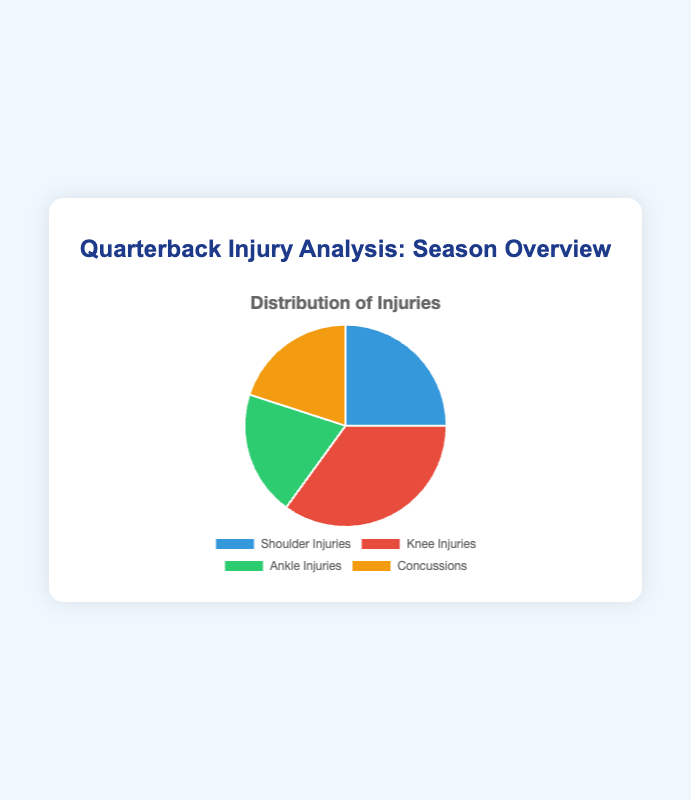Which injury type is the most common? By looking at the pie chart, the section representing knee injuries is the largest, with a percentage of 35%. Hence, knee injuries are the most common.
Answer: Knee Injuries What is the combined percentage of ankle injuries and concussions? The pie chart shows that ankle injuries and concussions each occupy 20% of the chart. Adding these together, 20% + 20% = 40%.
Answer: 40% Which injury types have the same percentage? The pie chart shows identical sizes for ankle injuries and concussions; each occupies 20%. Therefore, both have the same percentage.
Answer: Ankle Injuries and Concussions How does the percentage of shoulder injuries compare to knee injuries? The pie chart reveals that shoulder injuries account for 25%, whereas knee injuries account for 35%. This indicates that knee injuries are more frequent than shoulder injuries.
Answer: Knee Injuries are more frequent than Shoulder Injuries What percentage of injuries are neither knee injuries nor ankle injuries? The pie chart indicates that knee injuries are 35% and ankle injuries are 20%. Calculating the total percentage for both, we get 35% + 20% = 55%. Subtracting this from the total percentage (100%) gives 100% - 55% = 45%.
Answer: 45% Which section of the pie chart is represented by the blue color? According to the pie chart's color distribution, the blue section represents shoulder injuries.
Answer: Shoulder Injuries What is the percentage difference between shoulder injuries and ankle injuries? The pie chart indicates that shoulder injuries represent 25% and ankle injuries represent 20%. The difference between these percentages is 25% - 20% = 5%.
Answer: 5% If the total number of injuries is 100, how many of each type of injury is there? Given the percentages from the pie chart: 35% knee injuries, 25% shoulder injuries, 20% ankle injuries, and 20% concussions, we multiply each percentage by 100. Therefore, there would be 35 knee injuries, 25 shoulder injuries, 20 ankle injuries, and 20 concussions.
Answer: 35 knee, 25 shoulder, 20 ankle, and 20 concussions What proportion of the injuries involve the lower body (knee and ankle)? The chart shows that knee injuries constitute 35% and ankle injuries constitute 20%. Therefore, the proportion of lower body injuries is 35% + 20% = 55%.
Answer: 55% 